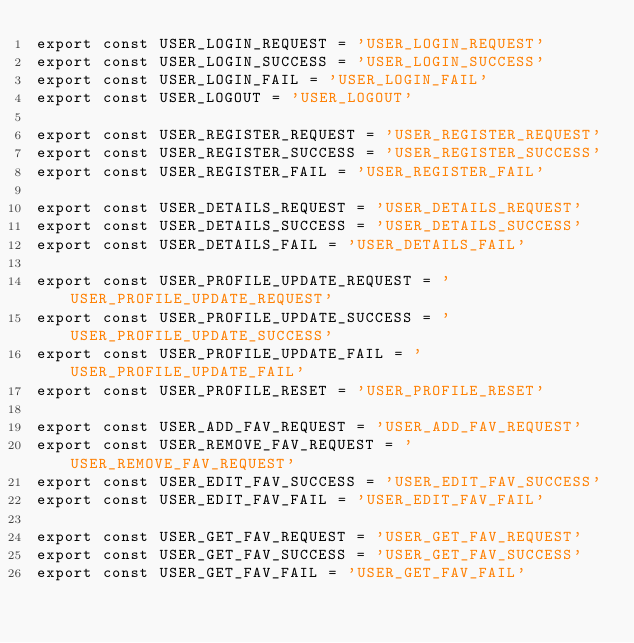Convert code to text. <code><loc_0><loc_0><loc_500><loc_500><_JavaScript_>export const USER_LOGIN_REQUEST = 'USER_LOGIN_REQUEST'
export const USER_LOGIN_SUCCESS = 'USER_LOGIN_SUCCESS'
export const USER_LOGIN_FAIL = 'USER_LOGIN_FAIL'
export const USER_LOGOUT = 'USER_LOGOUT'

export const USER_REGISTER_REQUEST = 'USER_REGISTER_REQUEST'
export const USER_REGISTER_SUCCESS = 'USER_REGISTER_SUCCESS'
export const USER_REGISTER_FAIL = 'USER_REGISTER_FAIL'

export const USER_DETAILS_REQUEST = 'USER_DETAILS_REQUEST'
export const USER_DETAILS_SUCCESS = 'USER_DETAILS_SUCCESS'
export const USER_DETAILS_FAIL = 'USER_DETAILS_FAIL'

export const USER_PROFILE_UPDATE_REQUEST = 'USER_PROFILE_UPDATE_REQUEST'
export const USER_PROFILE_UPDATE_SUCCESS = 'USER_PROFILE_UPDATE_SUCCESS'
export const USER_PROFILE_UPDATE_FAIL = 'USER_PROFILE_UPDATE_FAIL'
export const USER_PROFILE_RESET = 'USER_PROFILE_RESET'

export const USER_ADD_FAV_REQUEST = 'USER_ADD_FAV_REQUEST'
export const USER_REMOVE_FAV_REQUEST = 'USER_REMOVE_FAV_REQUEST'
export const USER_EDIT_FAV_SUCCESS = 'USER_EDIT_FAV_SUCCESS'
export const USER_EDIT_FAV_FAIL = 'USER_EDIT_FAV_FAIL'

export const USER_GET_FAV_REQUEST = 'USER_GET_FAV_REQUEST'
export const USER_GET_FAV_SUCCESS = 'USER_GET_FAV_SUCCESS'
export const USER_GET_FAV_FAIL = 'USER_GET_FAV_FAIL'</code> 